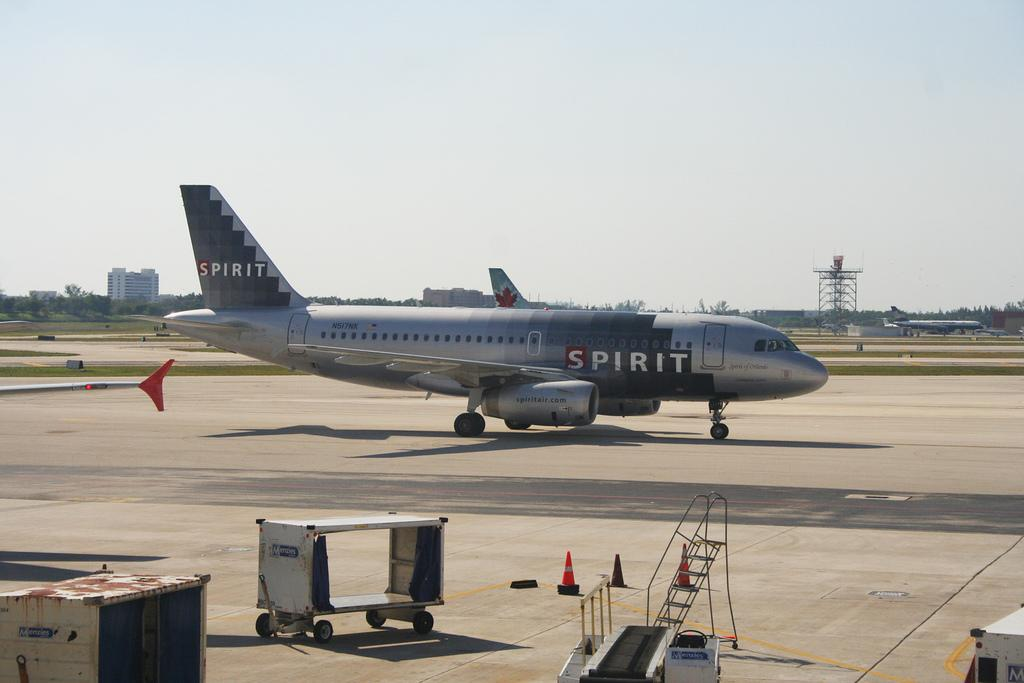Provide a one-sentence caption for the provided image. A large Spirit airplane that is dark gray in color. 